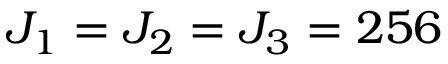Convert formula to latex. <formula><loc_0><loc_0><loc_500><loc_500>J _ { 1 } = J _ { 2 } = J _ { 3 } = 2 5 6</formula> 